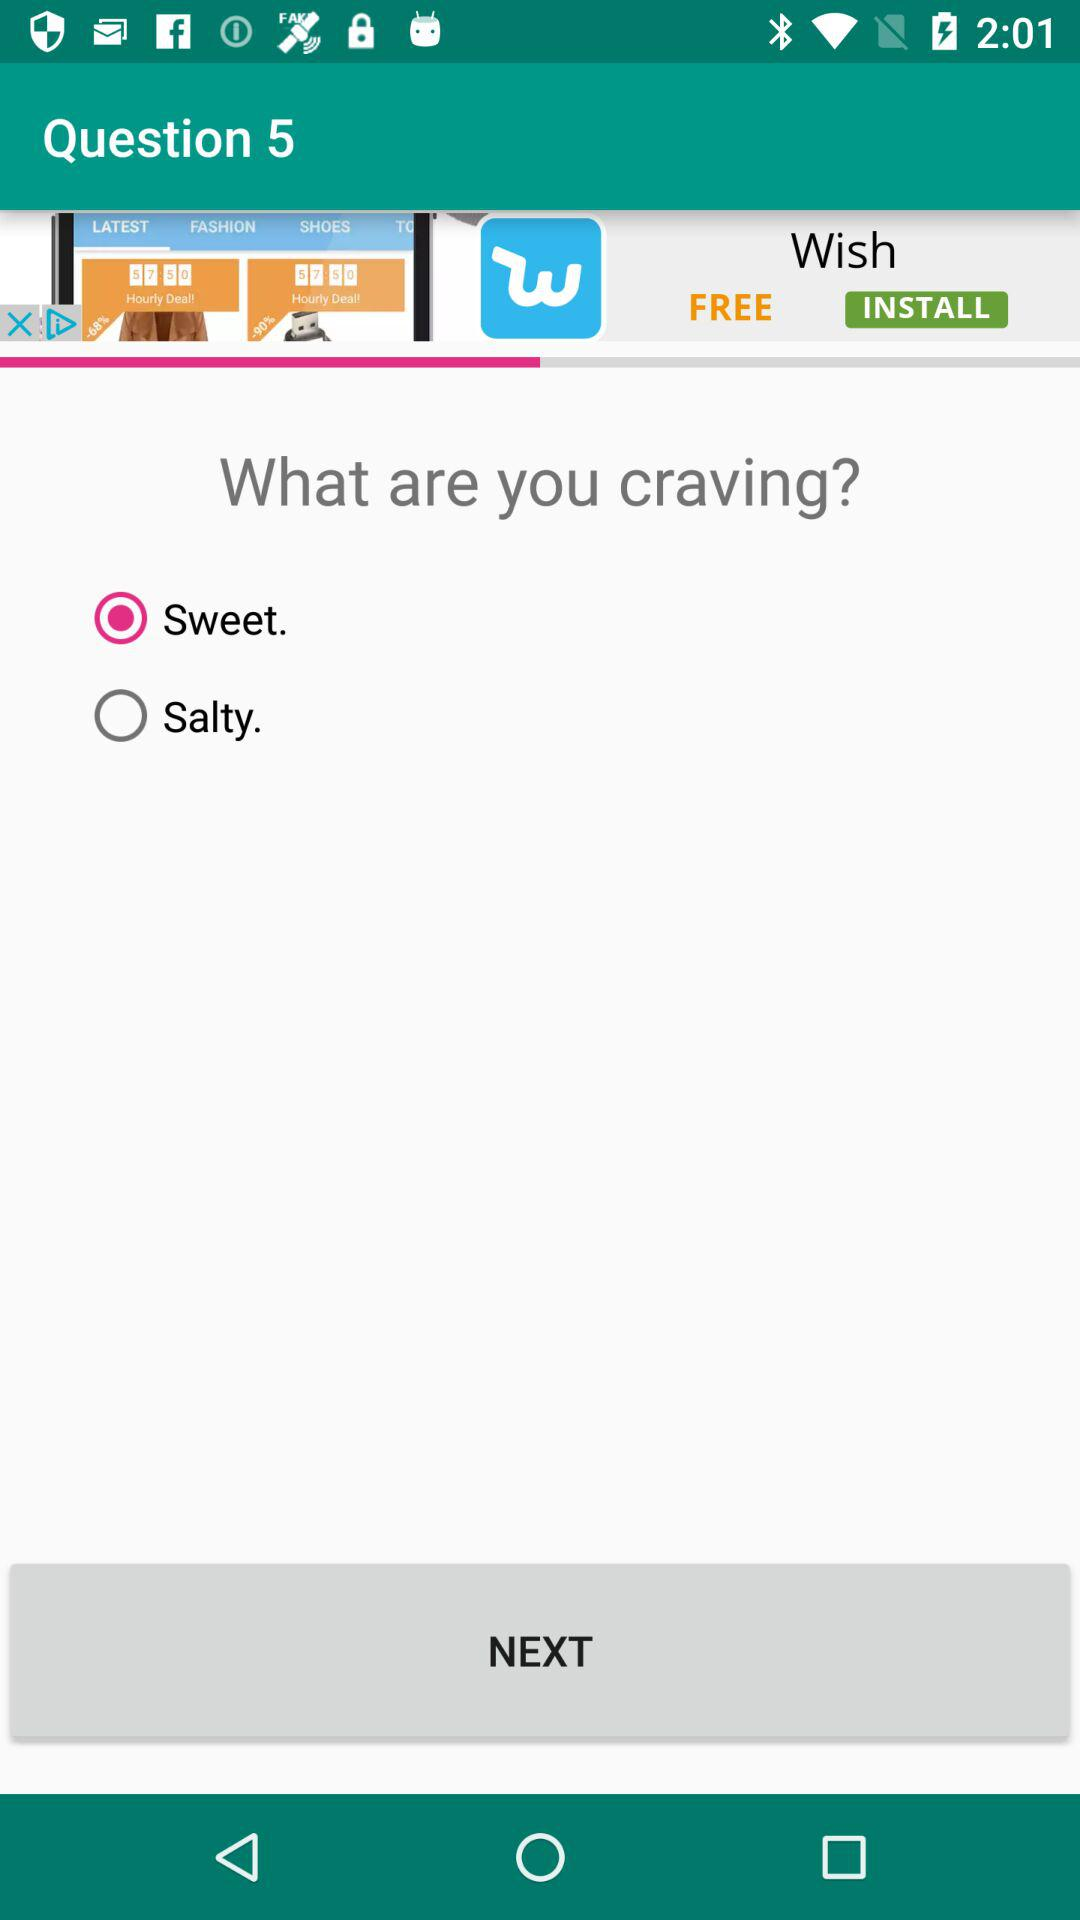Which craving is selected? The selected craving is "Sweet". 